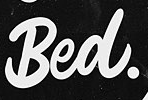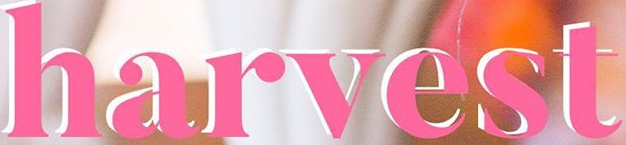What text appears in these images from left to right, separated by a semicolon? Bed.; harvest 